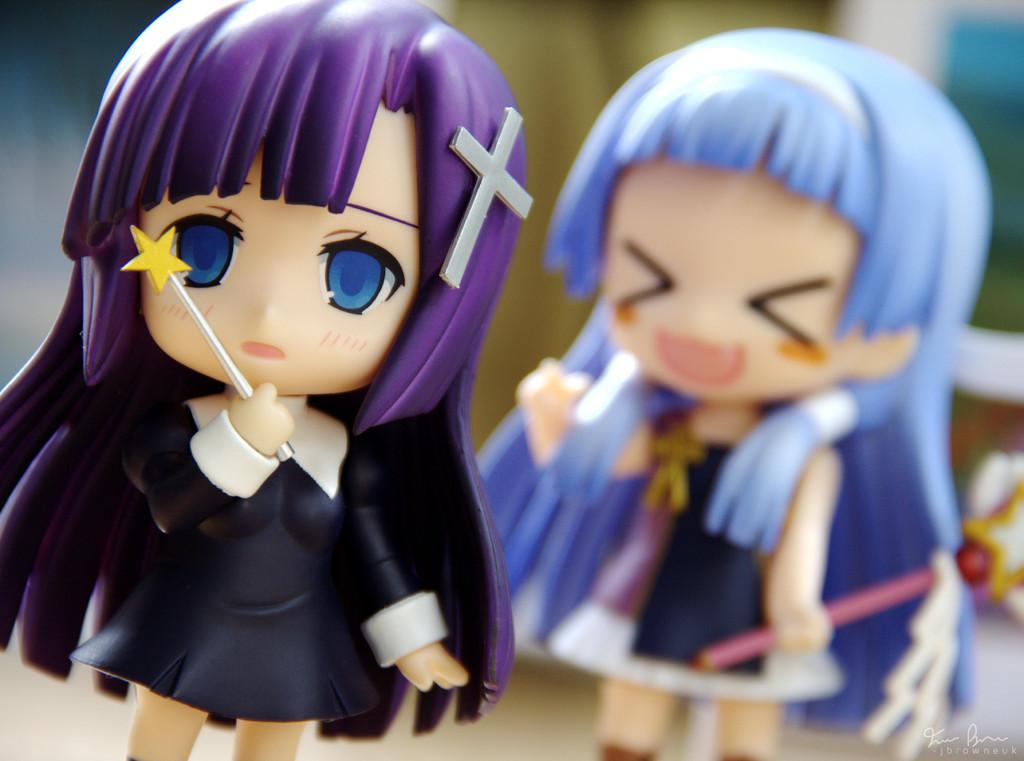Can you describe this image briefly? In this image we can see two dolls. There is a blur background in the image. 